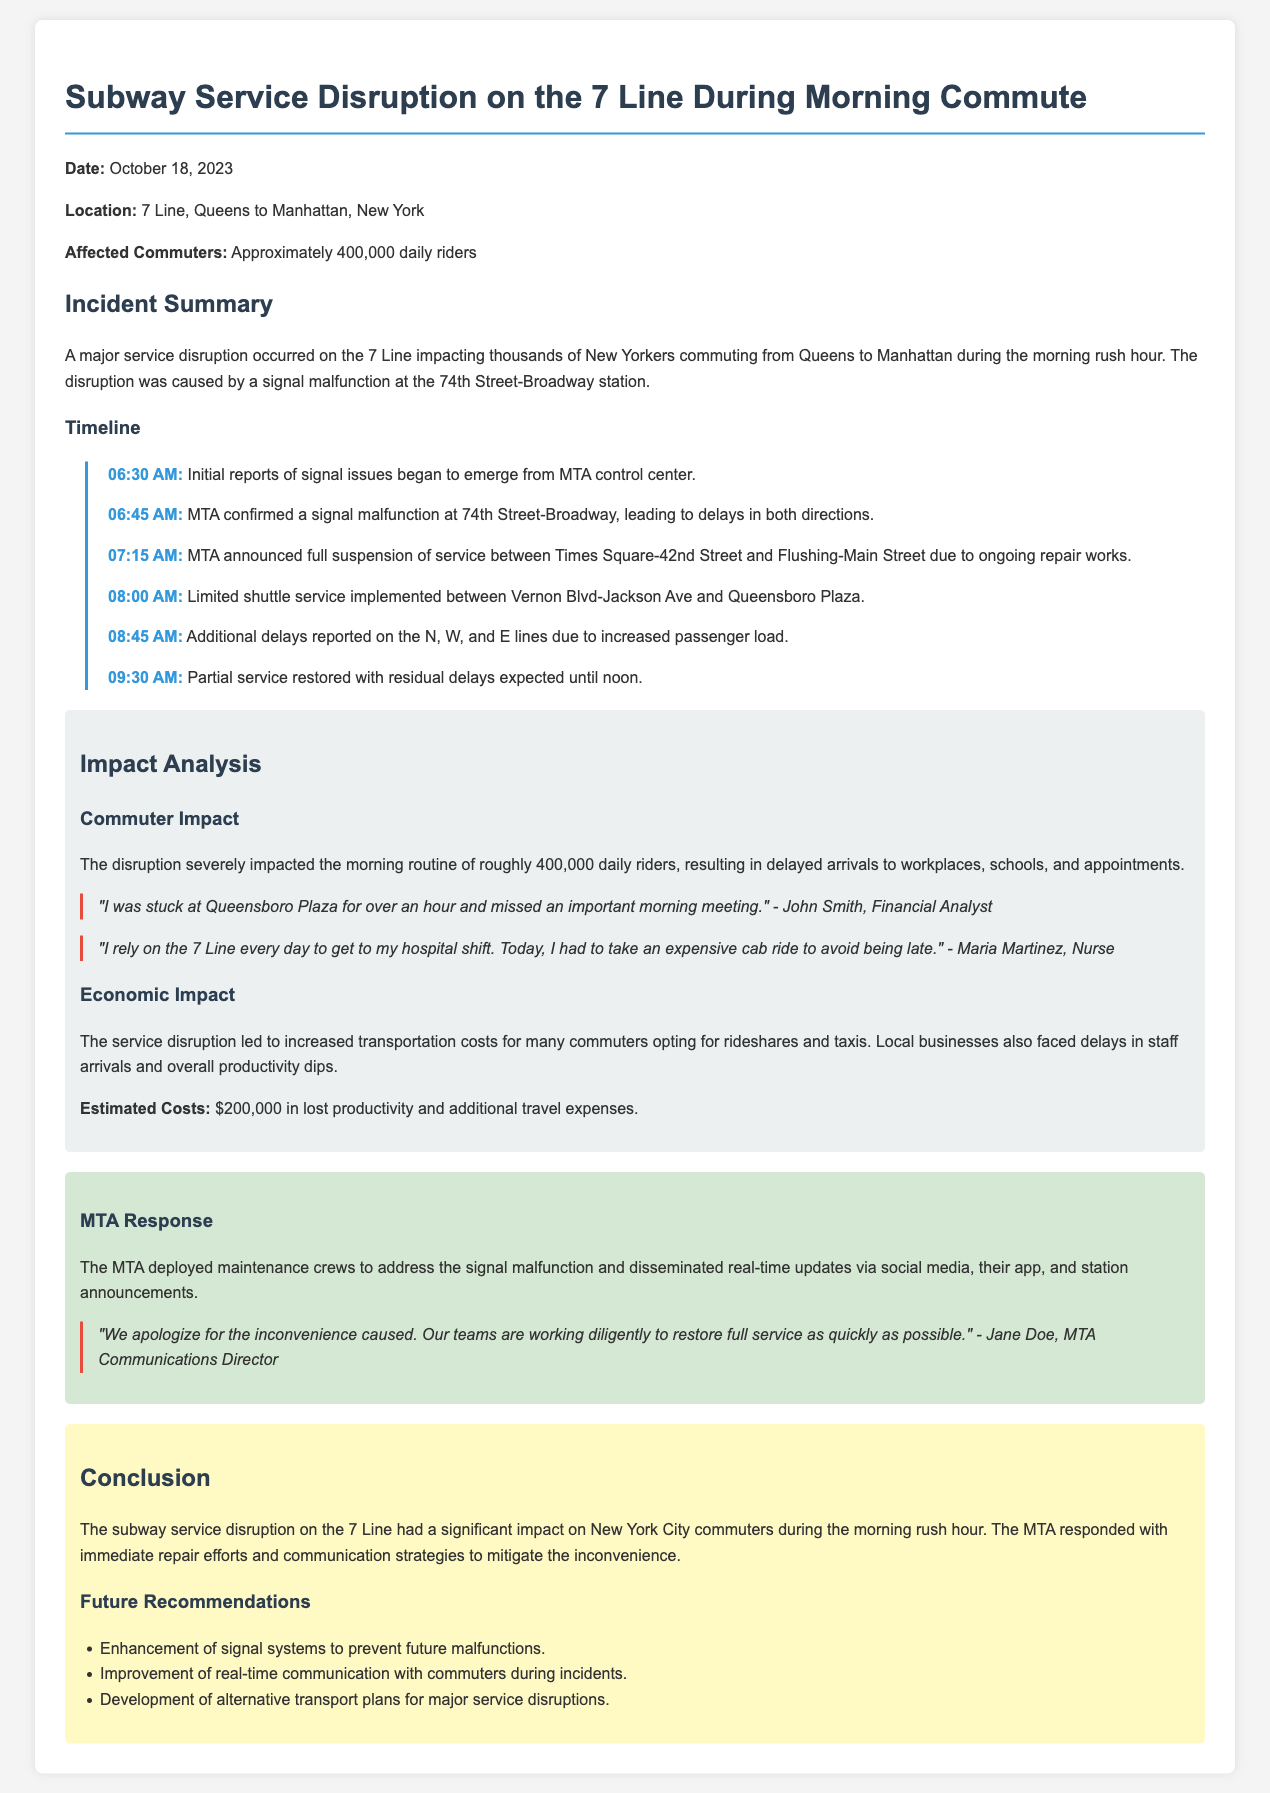What caused the service disruption? The service disruption was caused by a signal malfunction at the 74th Street-Broadway station.
Answer: signal malfunction How many daily riders were affected? Approximately 400,000 daily riders were impacted by the disruption during the morning commute.
Answer: 400,000 What time was the full suspension of service announced? MTA announced the full suspension of service at 07:15 AM due to ongoing repair works.
Answer: 07:15 AM What was the estimated economic cost of the service disruption? The estimated costs due to the service disruption were approximately $200,000 in lost productivity and additional travel expenses.
Answer: $200,000 Which lines experienced additional delays because of the disruption? Additional delays were reported on the N, W, and E lines due to increased passenger load.
Answer: N, W, and E lines What response did the MTA provide to the disruption? The MTA deployed maintenance crews to address the signal malfunction and provided real-time updates via various channels.
Answer: maintenance crews How did commuters express their frustration? Commuters expressed frustration through testimonials illustrating their inconvenience during the disruption.
Answer: testimonials What are the future recommendations mentioned in the report? Future recommendations include enhancement of signal systems and improvement of real-time communication with commuters.
Answer: enhancement of signal systems 